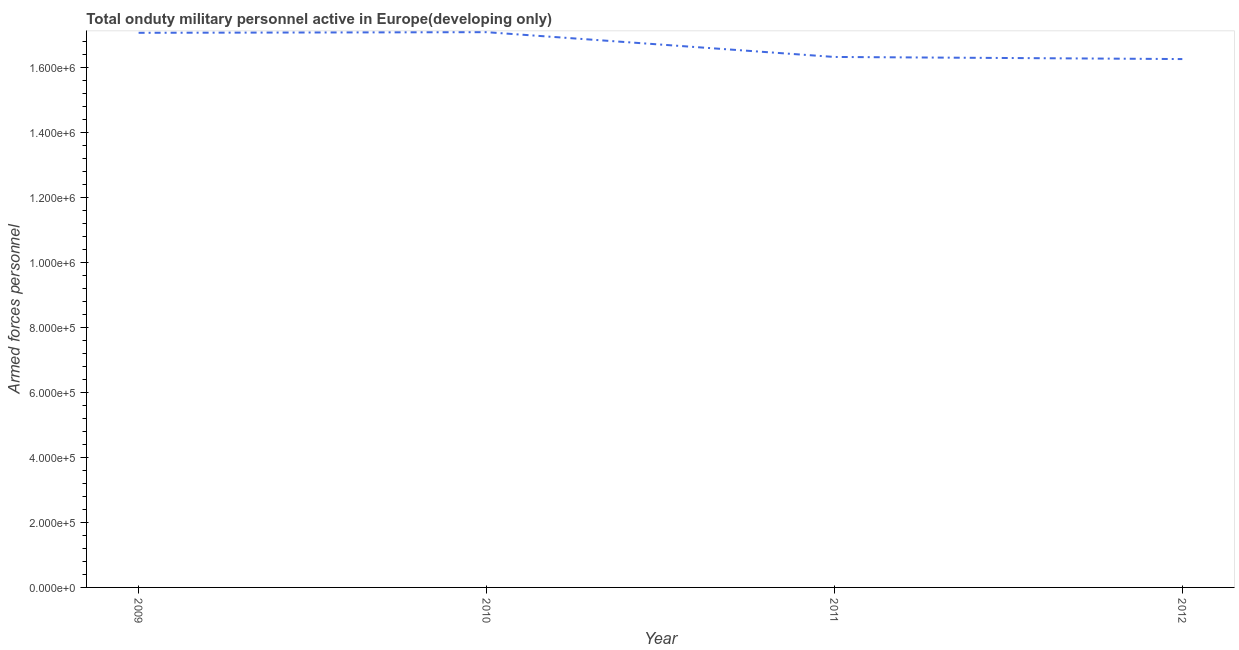What is the number of armed forces personnel in 2010?
Provide a short and direct response. 1.71e+06. Across all years, what is the maximum number of armed forces personnel?
Offer a terse response. 1.71e+06. Across all years, what is the minimum number of armed forces personnel?
Ensure brevity in your answer.  1.63e+06. What is the sum of the number of armed forces personnel?
Your response must be concise. 6.67e+06. What is the difference between the number of armed forces personnel in 2011 and 2012?
Offer a terse response. 6494. What is the average number of armed forces personnel per year?
Offer a terse response. 1.67e+06. What is the median number of armed forces personnel?
Keep it short and to the point. 1.67e+06. Do a majority of the years between 2009 and 2012 (inclusive) have number of armed forces personnel greater than 800000 ?
Your response must be concise. Yes. What is the ratio of the number of armed forces personnel in 2009 to that in 2011?
Offer a terse response. 1.05. Is the number of armed forces personnel in 2011 less than that in 2012?
Offer a terse response. No. Is the difference between the number of armed forces personnel in 2010 and 2012 greater than the difference between any two years?
Offer a terse response. Yes. What is the difference between the highest and the second highest number of armed forces personnel?
Ensure brevity in your answer.  1970. What is the difference between the highest and the lowest number of armed forces personnel?
Keep it short and to the point. 8.28e+04. How many lines are there?
Offer a very short reply. 1. How many years are there in the graph?
Provide a short and direct response. 4. What is the difference between two consecutive major ticks on the Y-axis?
Give a very brief answer. 2.00e+05. Does the graph contain grids?
Provide a short and direct response. No. What is the title of the graph?
Offer a terse response. Total onduty military personnel active in Europe(developing only). What is the label or title of the X-axis?
Offer a terse response. Year. What is the label or title of the Y-axis?
Provide a short and direct response. Armed forces personnel. What is the Armed forces personnel in 2009?
Give a very brief answer. 1.71e+06. What is the Armed forces personnel in 2010?
Keep it short and to the point. 1.71e+06. What is the Armed forces personnel of 2011?
Provide a short and direct response. 1.63e+06. What is the Armed forces personnel of 2012?
Provide a short and direct response. 1.63e+06. What is the difference between the Armed forces personnel in 2009 and 2010?
Give a very brief answer. -1970. What is the difference between the Armed forces personnel in 2009 and 2011?
Your answer should be compact. 7.43e+04. What is the difference between the Armed forces personnel in 2009 and 2012?
Your answer should be compact. 8.08e+04. What is the difference between the Armed forces personnel in 2010 and 2011?
Your answer should be very brief. 7.63e+04. What is the difference between the Armed forces personnel in 2010 and 2012?
Provide a short and direct response. 8.28e+04. What is the difference between the Armed forces personnel in 2011 and 2012?
Your response must be concise. 6494. What is the ratio of the Armed forces personnel in 2009 to that in 2011?
Your answer should be compact. 1.05. What is the ratio of the Armed forces personnel in 2009 to that in 2012?
Your response must be concise. 1.05. What is the ratio of the Armed forces personnel in 2010 to that in 2011?
Your answer should be very brief. 1.05. What is the ratio of the Armed forces personnel in 2010 to that in 2012?
Your answer should be compact. 1.05. What is the ratio of the Armed forces personnel in 2011 to that in 2012?
Give a very brief answer. 1. 